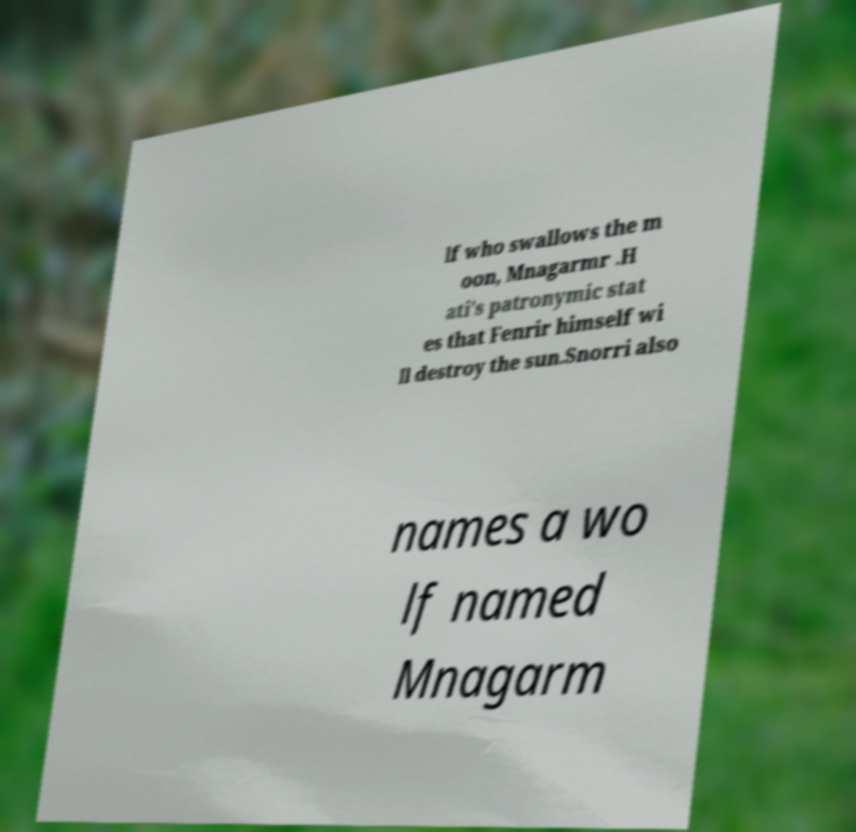Please read and relay the text visible in this image. What does it say? lf who swallows the m oon, Mnagarmr .H ati's patronymic stat es that Fenrir himself wi ll destroy the sun.Snorri also names a wo lf named Mnagarm 